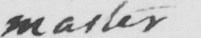What does this handwritten line say? master 